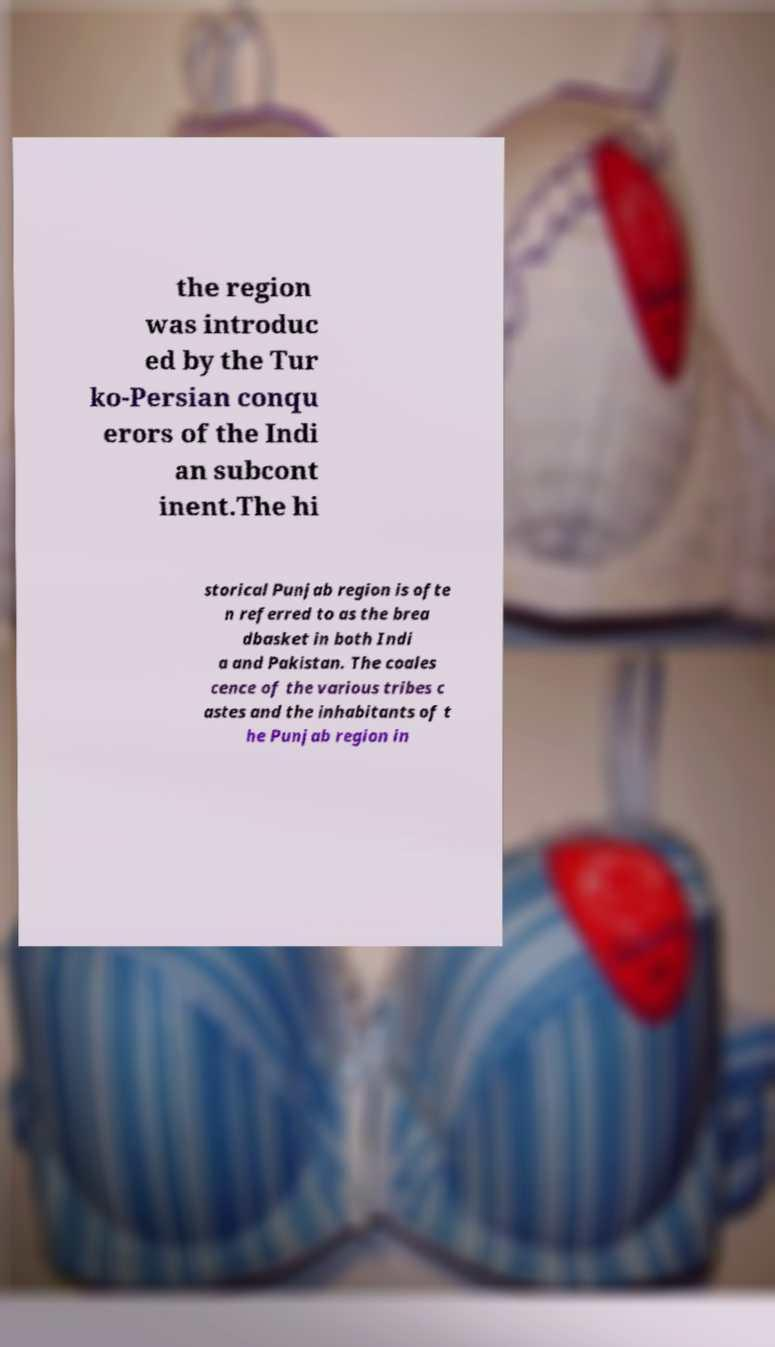For documentation purposes, I need the text within this image transcribed. Could you provide that? the region was introduc ed by the Tur ko-Persian conqu erors of the Indi an subcont inent.The hi storical Punjab region is ofte n referred to as the brea dbasket in both Indi a and Pakistan. The coales cence of the various tribes c astes and the inhabitants of t he Punjab region in 